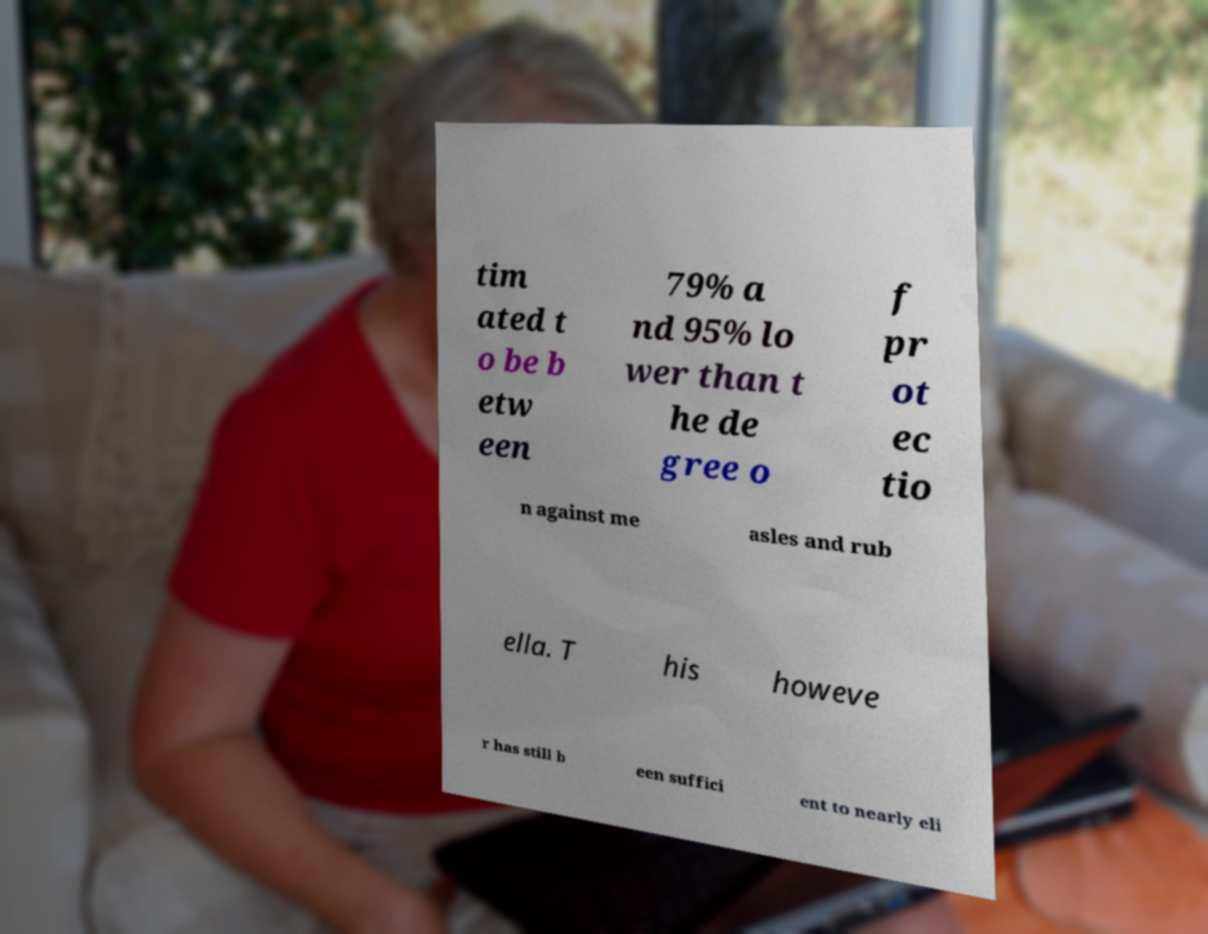There's text embedded in this image that I need extracted. Can you transcribe it verbatim? tim ated t o be b etw een 79% a nd 95% lo wer than t he de gree o f pr ot ec tio n against me asles and rub ella. T his howeve r has still b een suffici ent to nearly eli 